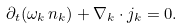Convert formula to latex. <formula><loc_0><loc_0><loc_500><loc_500>\partial _ { t } ( \omega _ { k } \, n _ { k } ) + \nabla _ { k } \cdot j _ { k } = 0 .</formula> 